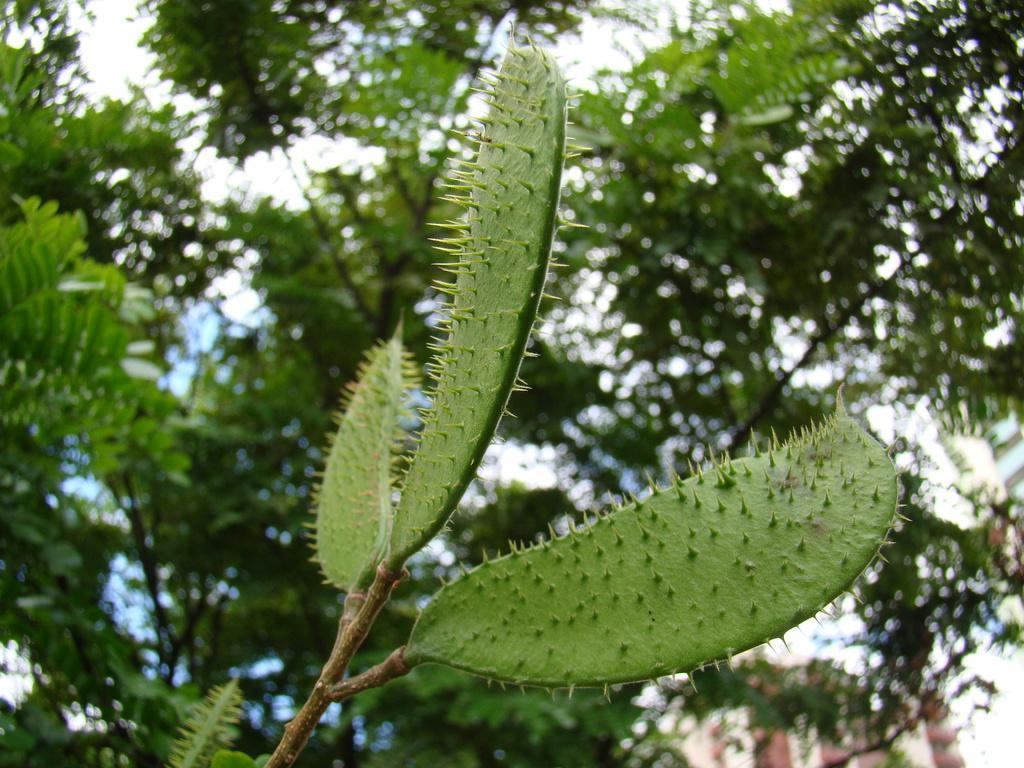Could you give a brief overview of what you see in this image? In the center of the image there is a plant with thorns. At the background of the image there is a tree. 